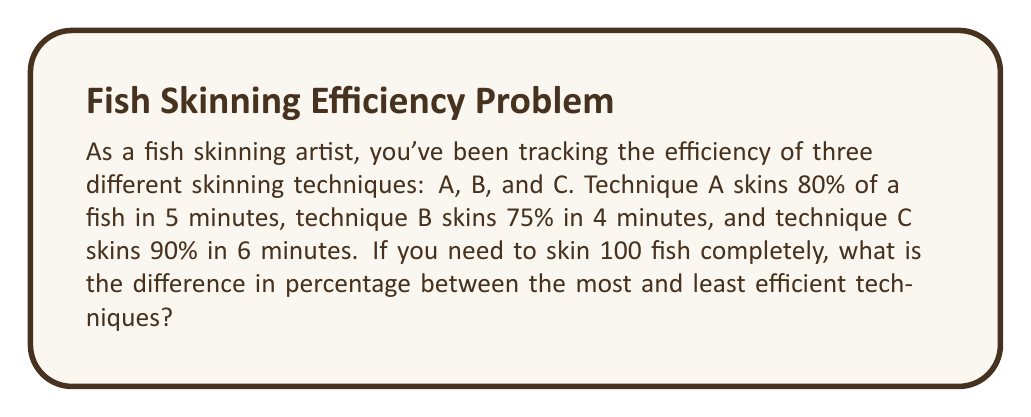Can you solve this math problem? 1. Calculate the percentage of fish skinned per minute for each technique:

   Technique A: $\frac{80\%}{5 \text{ minutes}} = 16\%$ per minute
   Technique B: $\frac{75\%}{4 \text{ minutes}} = 18.75\%$ per minute
   Technique C: $\frac{90\%}{6 \text{ minutes}} = 15\%$ per minute

2. Calculate the time needed to skin one fish completely (100%) for each technique:

   Technique A: $\frac{100\%}{16\% \text{ per minute}} = 6.25$ minutes
   Technique B: $\frac{100\%}{18.75\% \text{ per minute}} = 5.33$ minutes
   Technique C: $\frac{100\%}{15\% \text{ per minute}} = 6.67$ minutes

3. Calculate the total time needed to skin 100 fish for each technique:

   Technique A: $6.25 \times 100 = 625$ minutes
   Technique B: $5.33 \times 100 = 533$ minutes
   Technique C: $6.67 \times 100 = 667$ minutes

4. Identify the most and least efficient techniques:
   
   Most efficient: Technique B (533 minutes)
   Least efficient: Technique C (667 minutes)

5. Calculate the percentage difference:

   Percentage difference = $\frac{\text{Difference in time}}{\text{Time of least efficient}} \times 100\%$
   
   $= \frac{667 - 533}{667} \times 100\% = \frac{134}{667} \times 100\% \approx 20.09\%$
Answer: 20.09% 